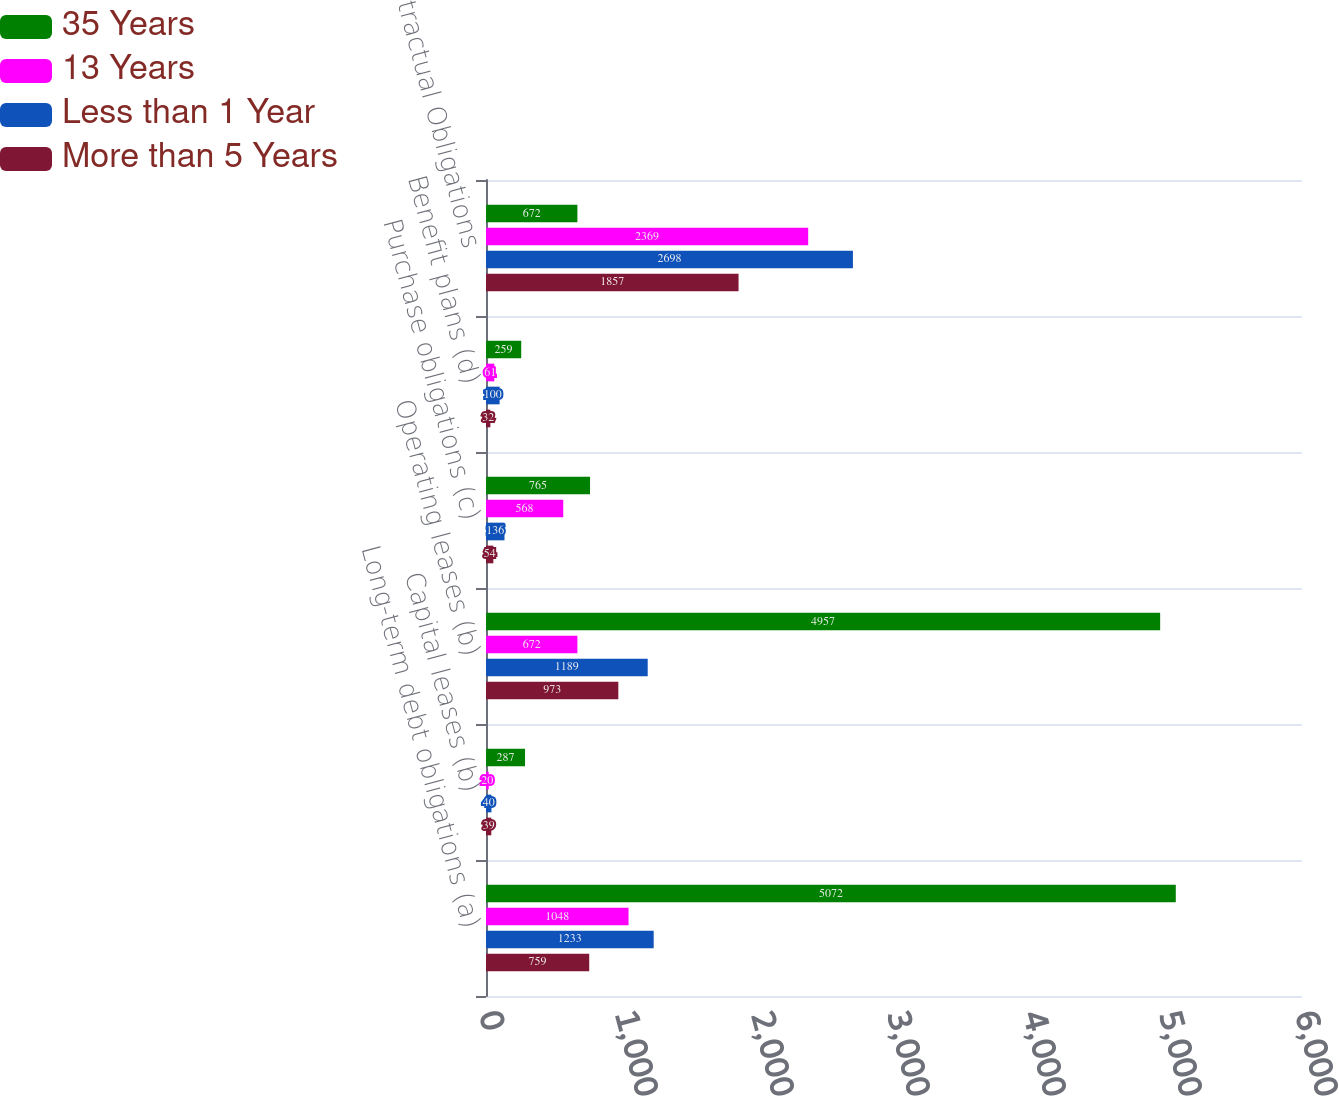Convert chart. <chart><loc_0><loc_0><loc_500><loc_500><stacked_bar_chart><ecel><fcel>Long-term debt obligations (a)<fcel>Capital leases (b)<fcel>Operating leases (b)<fcel>Purchase obligations (c)<fcel>Benefit plans (d)<fcel>Total Contractual Obligations<nl><fcel>35 Years<fcel>5072<fcel>287<fcel>4957<fcel>765<fcel>259<fcel>672<nl><fcel>13 Years<fcel>1048<fcel>20<fcel>672<fcel>568<fcel>61<fcel>2369<nl><fcel>Less than 1 Year<fcel>1233<fcel>40<fcel>1189<fcel>136<fcel>100<fcel>2698<nl><fcel>More than 5 Years<fcel>759<fcel>39<fcel>973<fcel>54<fcel>32<fcel>1857<nl></chart> 